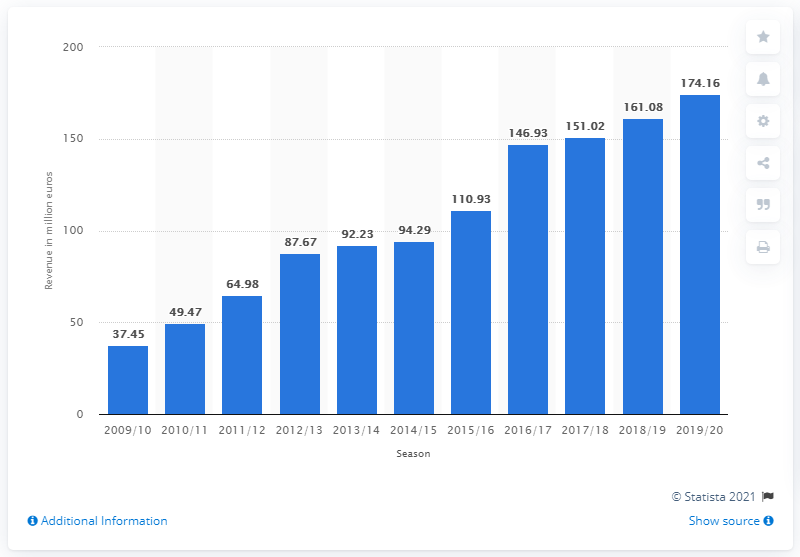Mention a couple of crucial points in this snapshot. The expenses for Borussia Dortmund's professional squad amounted to 174.16 million euros in the 2019/20 season. 